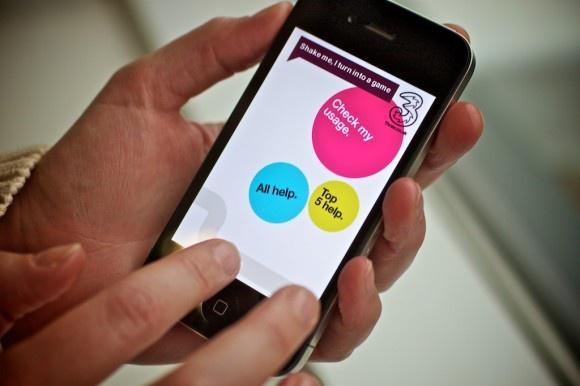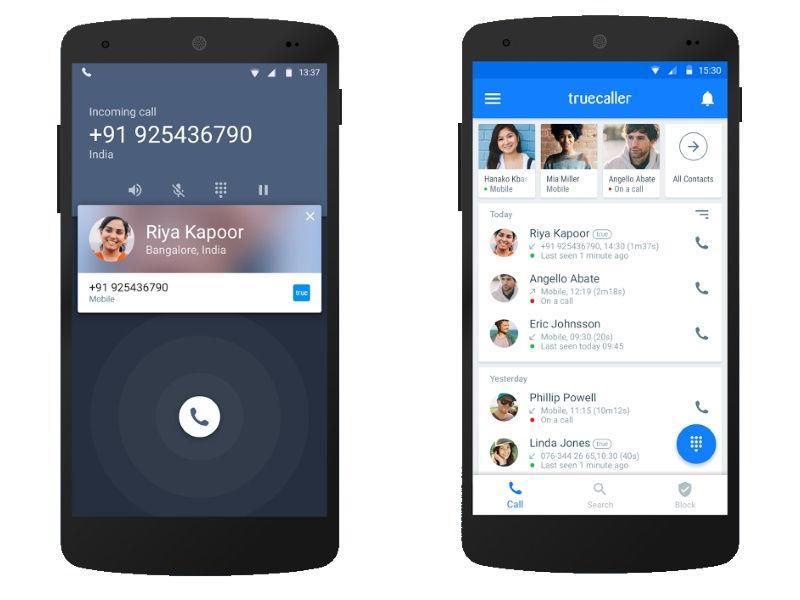The first image is the image on the left, the second image is the image on the right. Examine the images to the left and right. Is the description "One of the images shows a cell phone that has three differently colored circles on the screen." accurate? Answer yes or no. Yes. The first image is the image on the left, the second image is the image on the right. Analyze the images presented: Is the assertion "One image shows two side by side phones displayed screen-first and head-on, and the other image shows a row of three screen-first phones that are not overlapping." valid? Answer yes or no. No. 